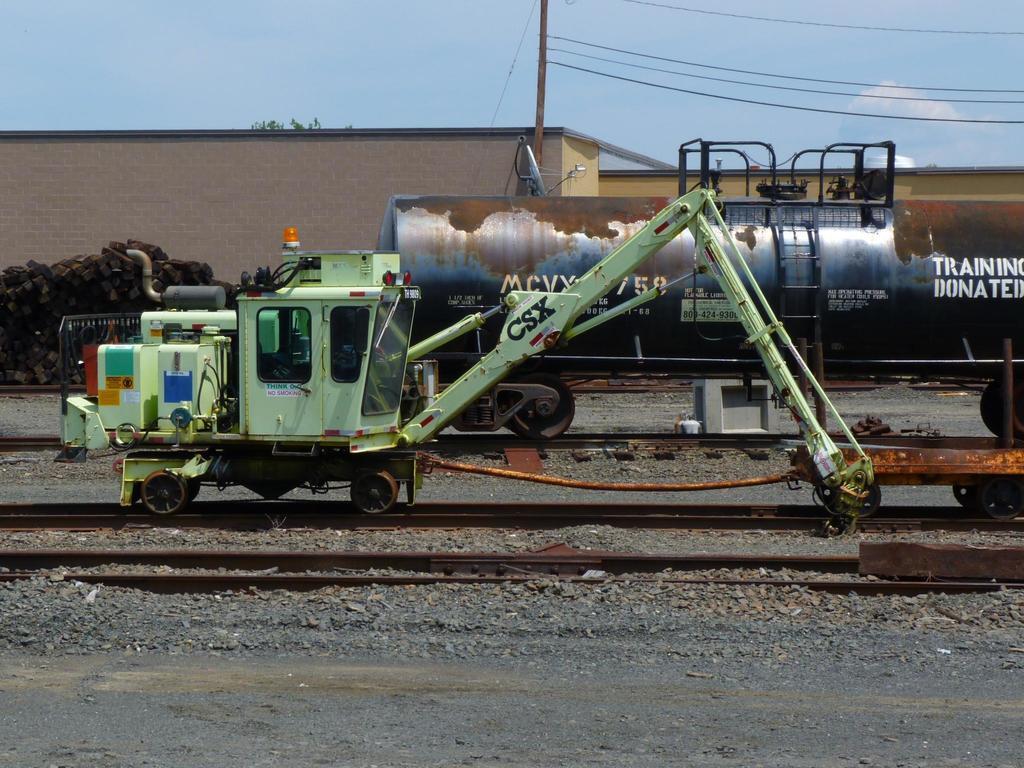Describe this image in one or two sentences. This image is taken outdoors. At the top of the image there is the sky with clouds. At the bottom of the image there is a ground and there is a house. There are a few wooden sticks and there is a pole with a few wires. In the middle of the image a vehicle is parked on the track. There are two tracks and a truck is parked on the road. 